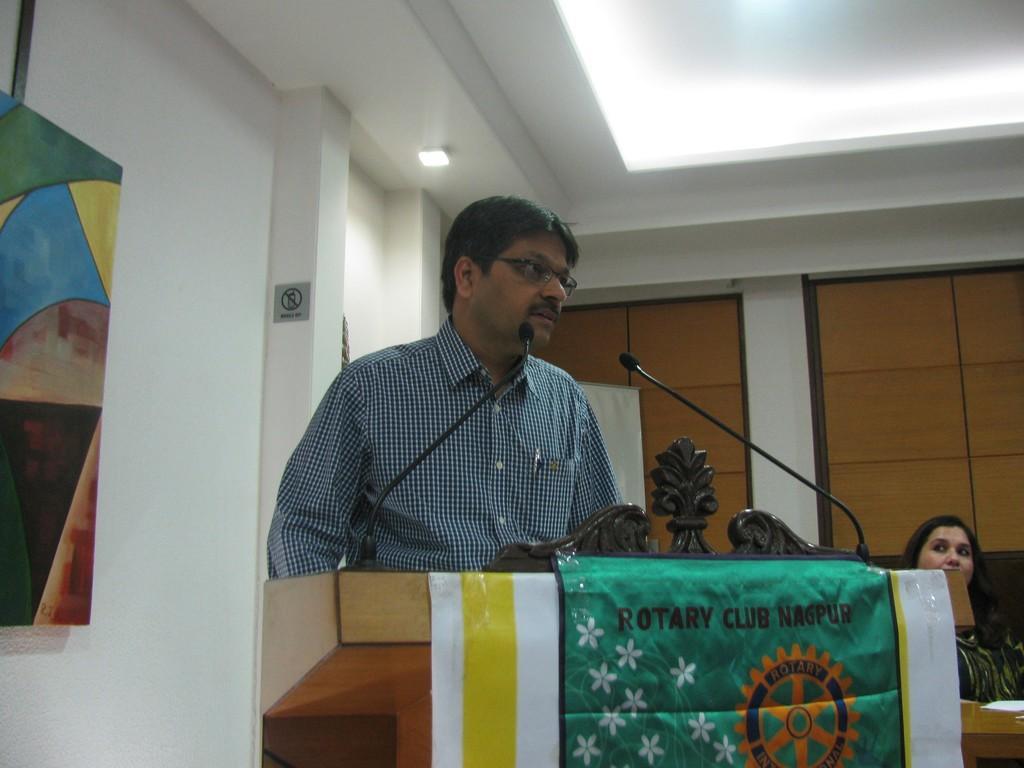In one or two sentences, can you explain what this image depicts? In this image we can see a man wearing specs. In front of him there is a podium with mics and banner with text and log. There is a lady sitting. There is a wall with photo frames. On the ceiling there are lights. 